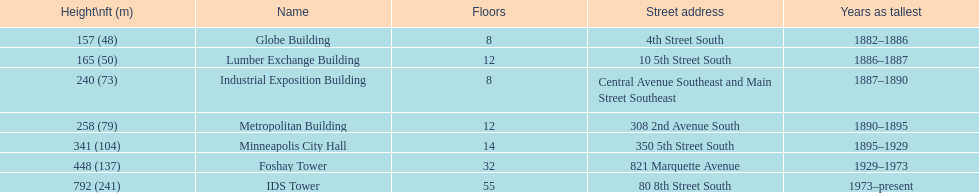How tall is it to the top of the ids tower in feet? 792. 